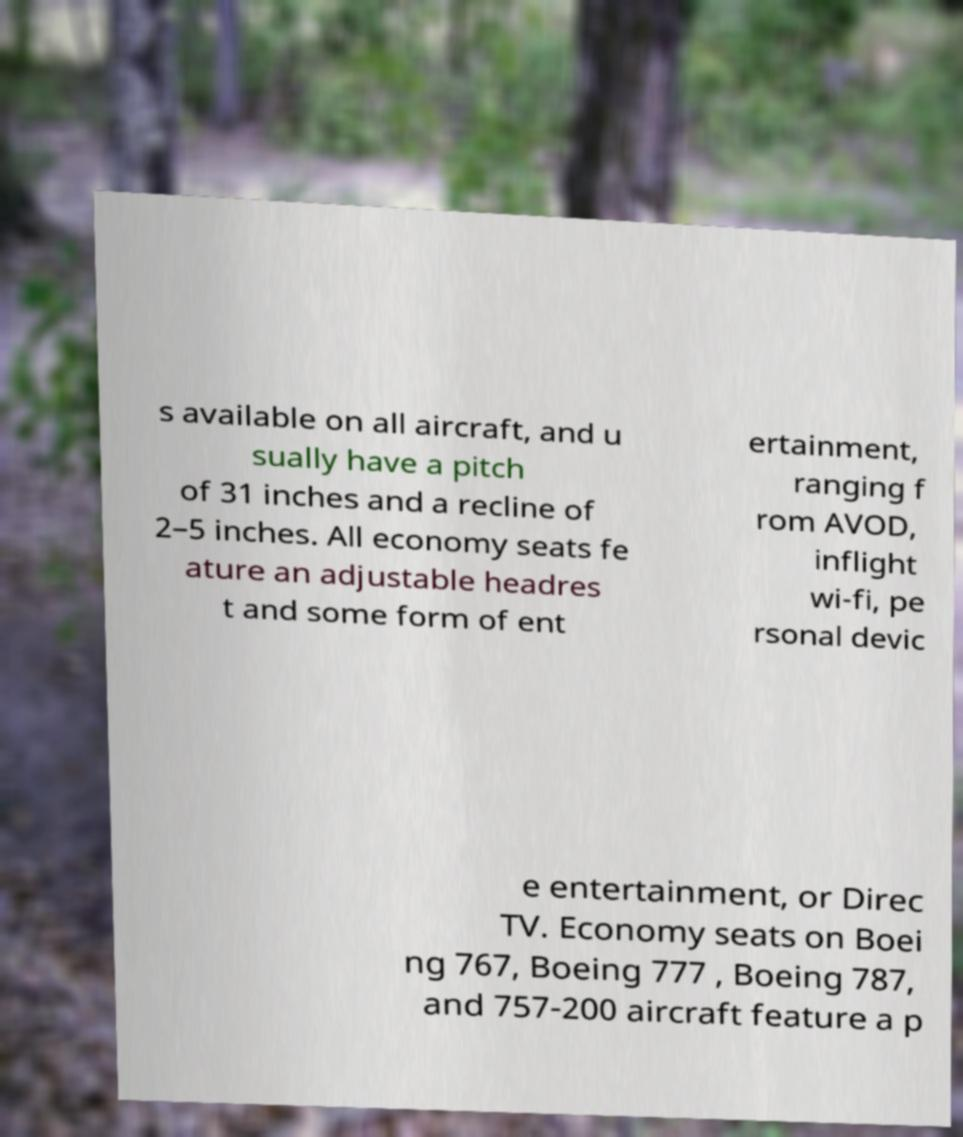Can you read and provide the text displayed in the image?This photo seems to have some interesting text. Can you extract and type it out for me? s available on all aircraft, and u sually have a pitch of 31 inches and a recline of 2–5 inches. All economy seats fe ature an adjustable headres t and some form of ent ertainment, ranging f rom AVOD, inflight wi-fi, pe rsonal devic e entertainment, or Direc TV. Economy seats on Boei ng 767, Boeing 777 , Boeing 787, and 757-200 aircraft feature a p 